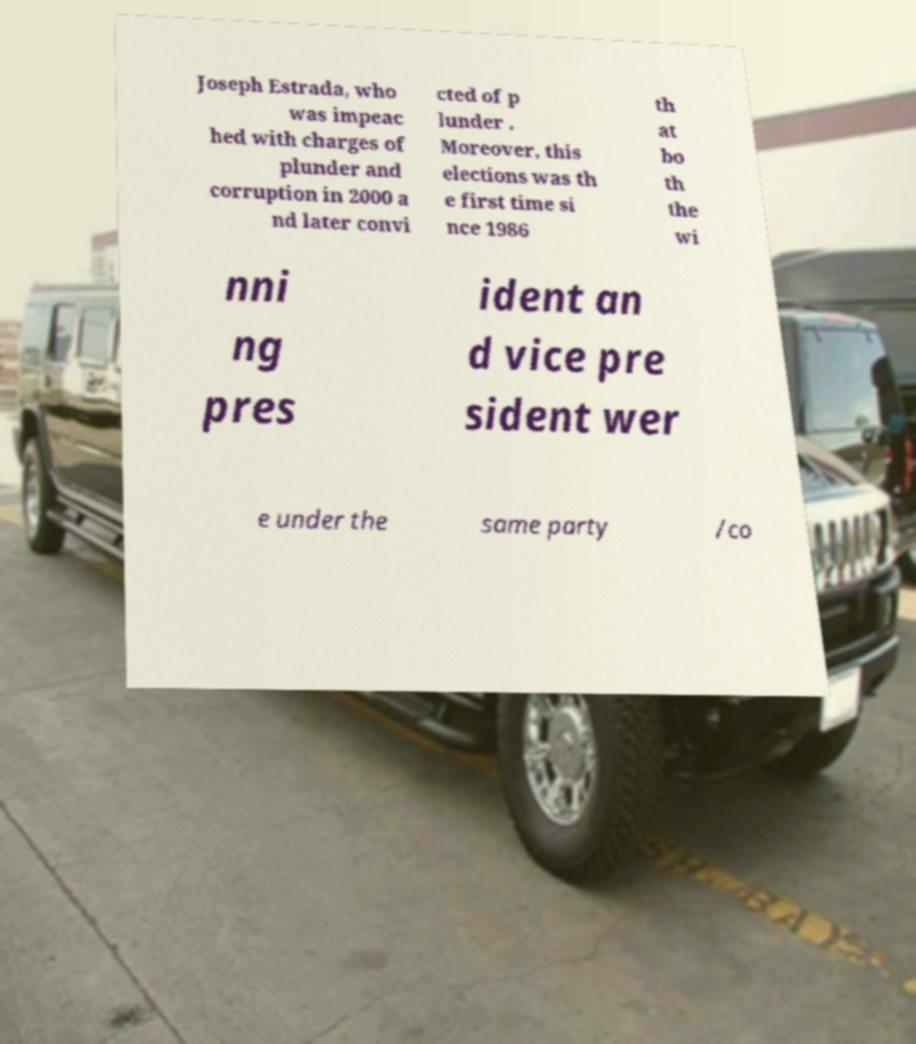Could you extract and type out the text from this image? Joseph Estrada, who was impeac hed with charges of plunder and corruption in 2000 a nd later convi cted of p lunder . Moreover, this elections was th e first time si nce 1986 th at bo th the wi nni ng pres ident an d vice pre sident wer e under the same party /co 